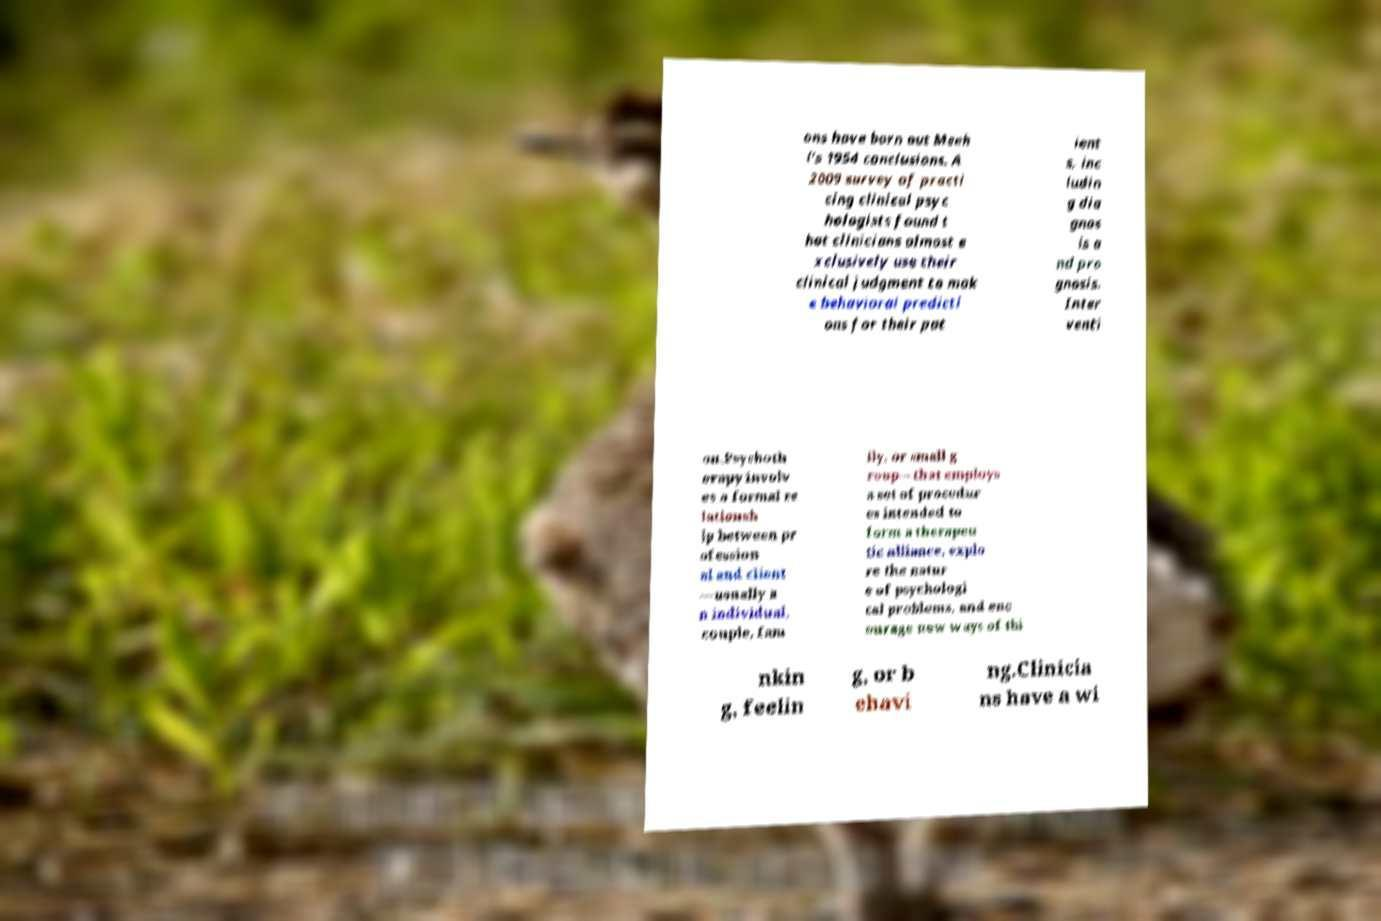I need the written content from this picture converted into text. Can you do that? ons have born out Meeh l's 1954 conclusions. A 2009 survey of practi cing clinical psyc hologists found t hat clinicians almost e xclusively use their clinical judgment to mak e behavioral predicti ons for their pat ient s, inc ludin g dia gnos is a nd pro gnosis. Inter venti on.Psychoth erapy involv es a formal re lationsh ip between pr ofession al and client —usually a n individual, couple, fam ily, or small g roup—that employs a set of procedur es intended to form a therapeu tic alliance, explo re the natur e of psychologi cal problems, and enc ourage new ways of thi nkin g, feelin g, or b ehavi ng.Clinicia ns have a wi 